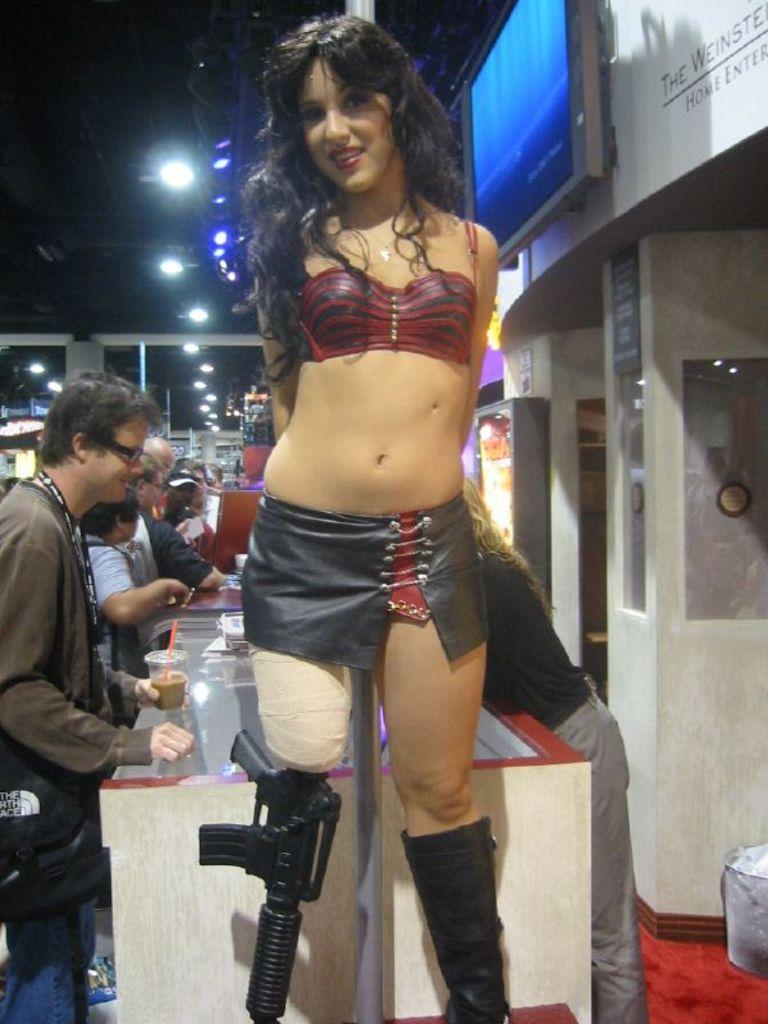How many people are in the image? There is a group of people in the image. What can be seen on the screen in the image? Unfortunately, the facts provided do not give any information about the content of the screen. What is the person holding in the image? One person is holding a glass in the image. What can be seen in the background of the image? There are lights visible in the background of the image. What type of yam is being printed by the brothers in the image? There is no yam or brothers present in the image. What type of print can be seen on the screen in the image? Unfortunately, the facts provided do not give any information about the content of the screen. 